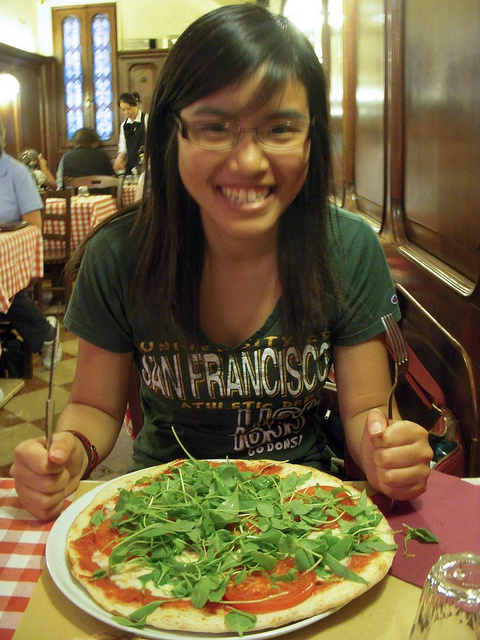Describe the objects in this image and their specific colors. I can see people in lightyellow, black, maroon, and brown tones, pizza in lightyellow, green, olive, darkgreen, and khaki tones, dining table in lightyellow, brown, and tan tones, people in lightyellow, darkgray, black, and olive tones, and cup in lightyellow, tan, gray, khaki, and white tones in this image. 